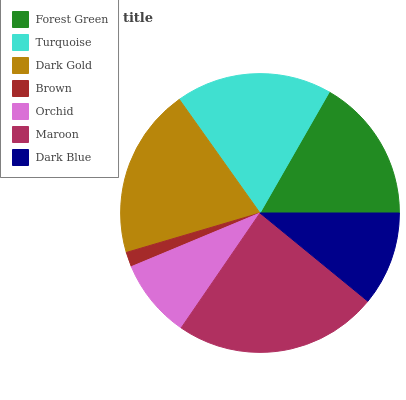Is Brown the minimum?
Answer yes or no. Yes. Is Maroon the maximum?
Answer yes or no. Yes. Is Turquoise the minimum?
Answer yes or no. No. Is Turquoise the maximum?
Answer yes or no. No. Is Turquoise greater than Forest Green?
Answer yes or no. Yes. Is Forest Green less than Turquoise?
Answer yes or no. Yes. Is Forest Green greater than Turquoise?
Answer yes or no. No. Is Turquoise less than Forest Green?
Answer yes or no. No. Is Forest Green the high median?
Answer yes or no. Yes. Is Forest Green the low median?
Answer yes or no. Yes. Is Maroon the high median?
Answer yes or no. No. Is Dark Blue the low median?
Answer yes or no. No. 